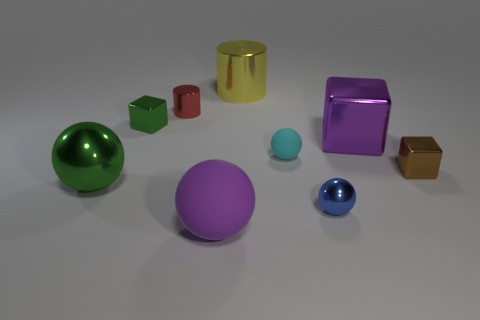Is the number of spheres that are behind the large yellow thing less than the number of blue metallic objects?
Provide a short and direct response. Yes. There is a large ball that is the same material as the small red thing; what color is it?
Offer a terse response. Green. There is a purple thing in front of the tiny cyan ball; how big is it?
Give a very brief answer. Large. Is the green block made of the same material as the purple sphere?
Offer a very short reply. No. There is a tiny metallic cube behind the ball that is behind the green metal ball; are there any things behind it?
Keep it short and to the point. Yes. What color is the big cylinder?
Provide a short and direct response. Yellow. What is the color of the metal ball that is the same size as the brown metal cube?
Your response must be concise. Blue. Is the shape of the big purple object that is to the right of the cyan rubber thing the same as  the tiny green shiny object?
Provide a short and direct response. Yes. What is the color of the rubber object that is on the right side of the big metal thing that is behind the green block that is to the left of the small brown thing?
Provide a short and direct response. Cyan. Are any big red matte blocks visible?
Your answer should be very brief. No. 